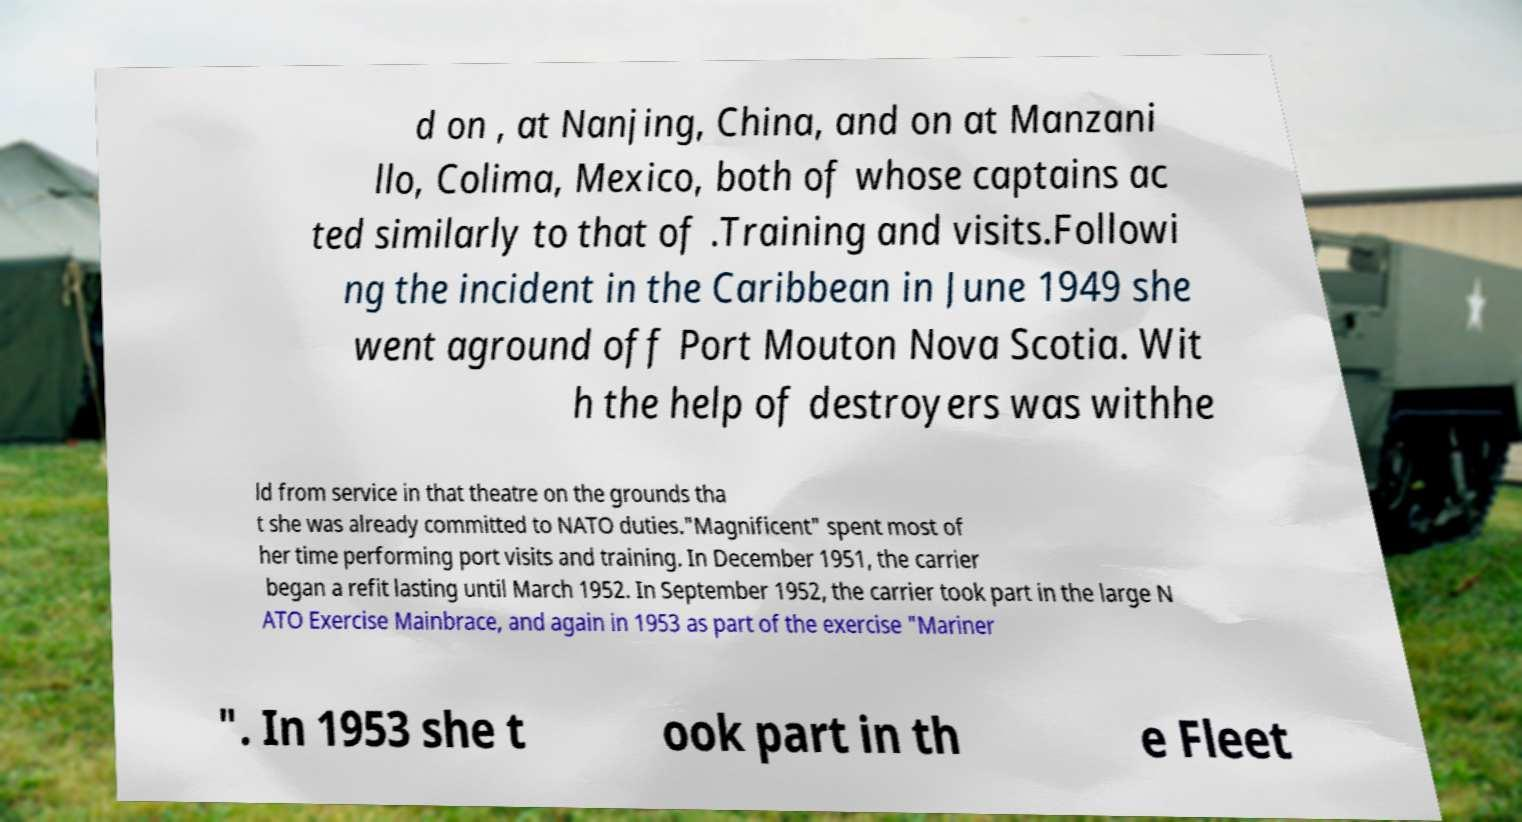Please read and relay the text visible in this image. What does it say? d on , at Nanjing, China, and on at Manzani llo, Colima, Mexico, both of whose captains ac ted similarly to that of .Training and visits.Followi ng the incident in the Caribbean in June 1949 she went aground off Port Mouton Nova Scotia. Wit h the help of destroyers was withhe ld from service in that theatre on the grounds tha t she was already committed to NATO duties."Magnificent" spent most of her time performing port visits and training. In December 1951, the carrier began a refit lasting until March 1952. In September 1952, the carrier took part in the large N ATO Exercise Mainbrace, and again in 1953 as part of the exercise "Mariner ". In 1953 she t ook part in th e Fleet 